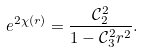<formula> <loc_0><loc_0><loc_500><loc_500>e ^ { 2 \chi ( r ) } = \frac { \mathcal { C } _ { 2 } ^ { 2 } } { 1 - \mathcal { C } _ { 3 } ^ { 2 } r ^ { 2 } } .</formula> 